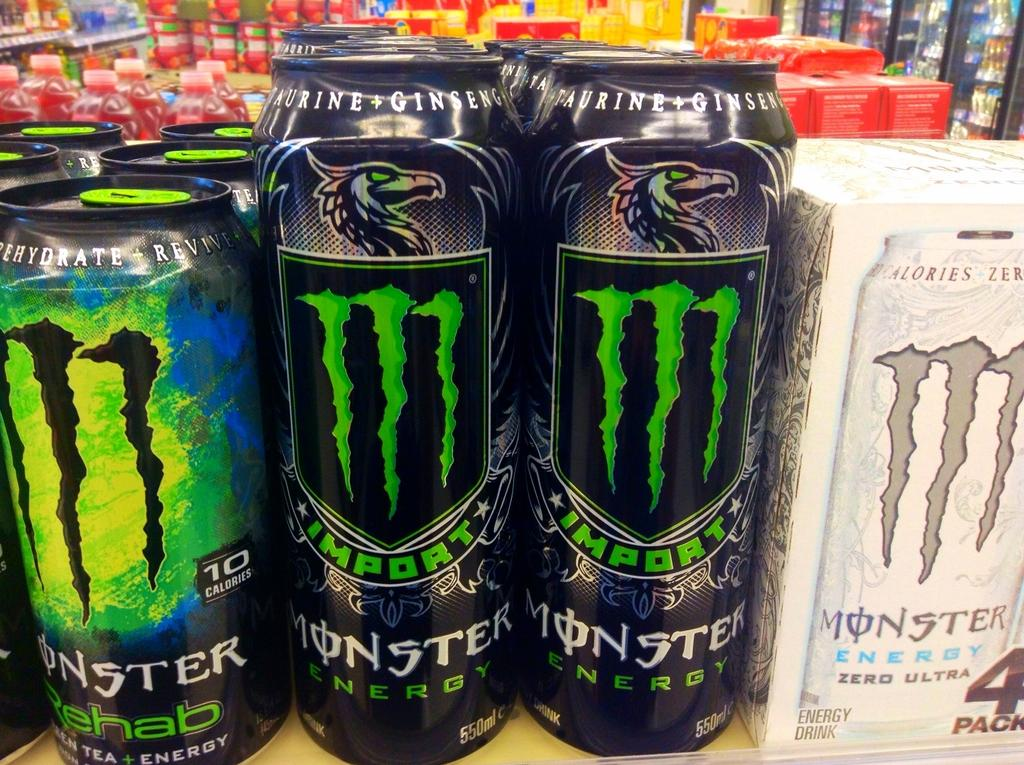<image>
Provide a brief description of the given image. Several different Monsters cans, including MONSTER Rehab, IMPORT MONSTER ENERGY, and MONSTER ENERGY ZERO ULTRA. 